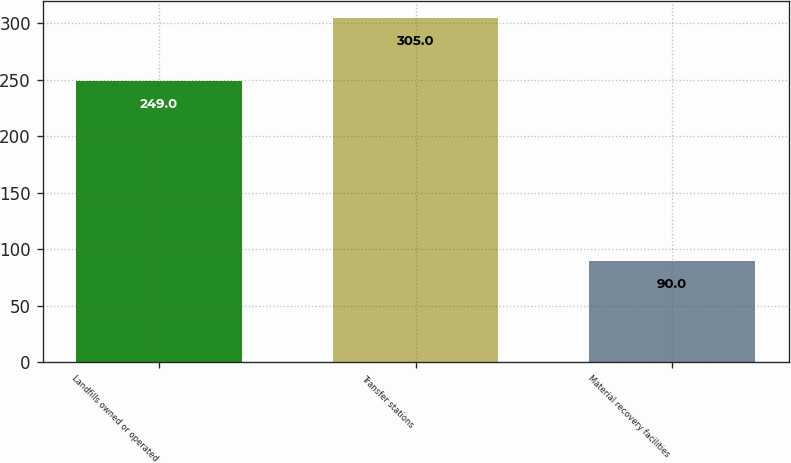Convert chart to OTSL. <chart><loc_0><loc_0><loc_500><loc_500><bar_chart><fcel>Landfills owned or operated<fcel>Transfer stations<fcel>Material recovery facilities<nl><fcel>249<fcel>305<fcel>90<nl></chart> 